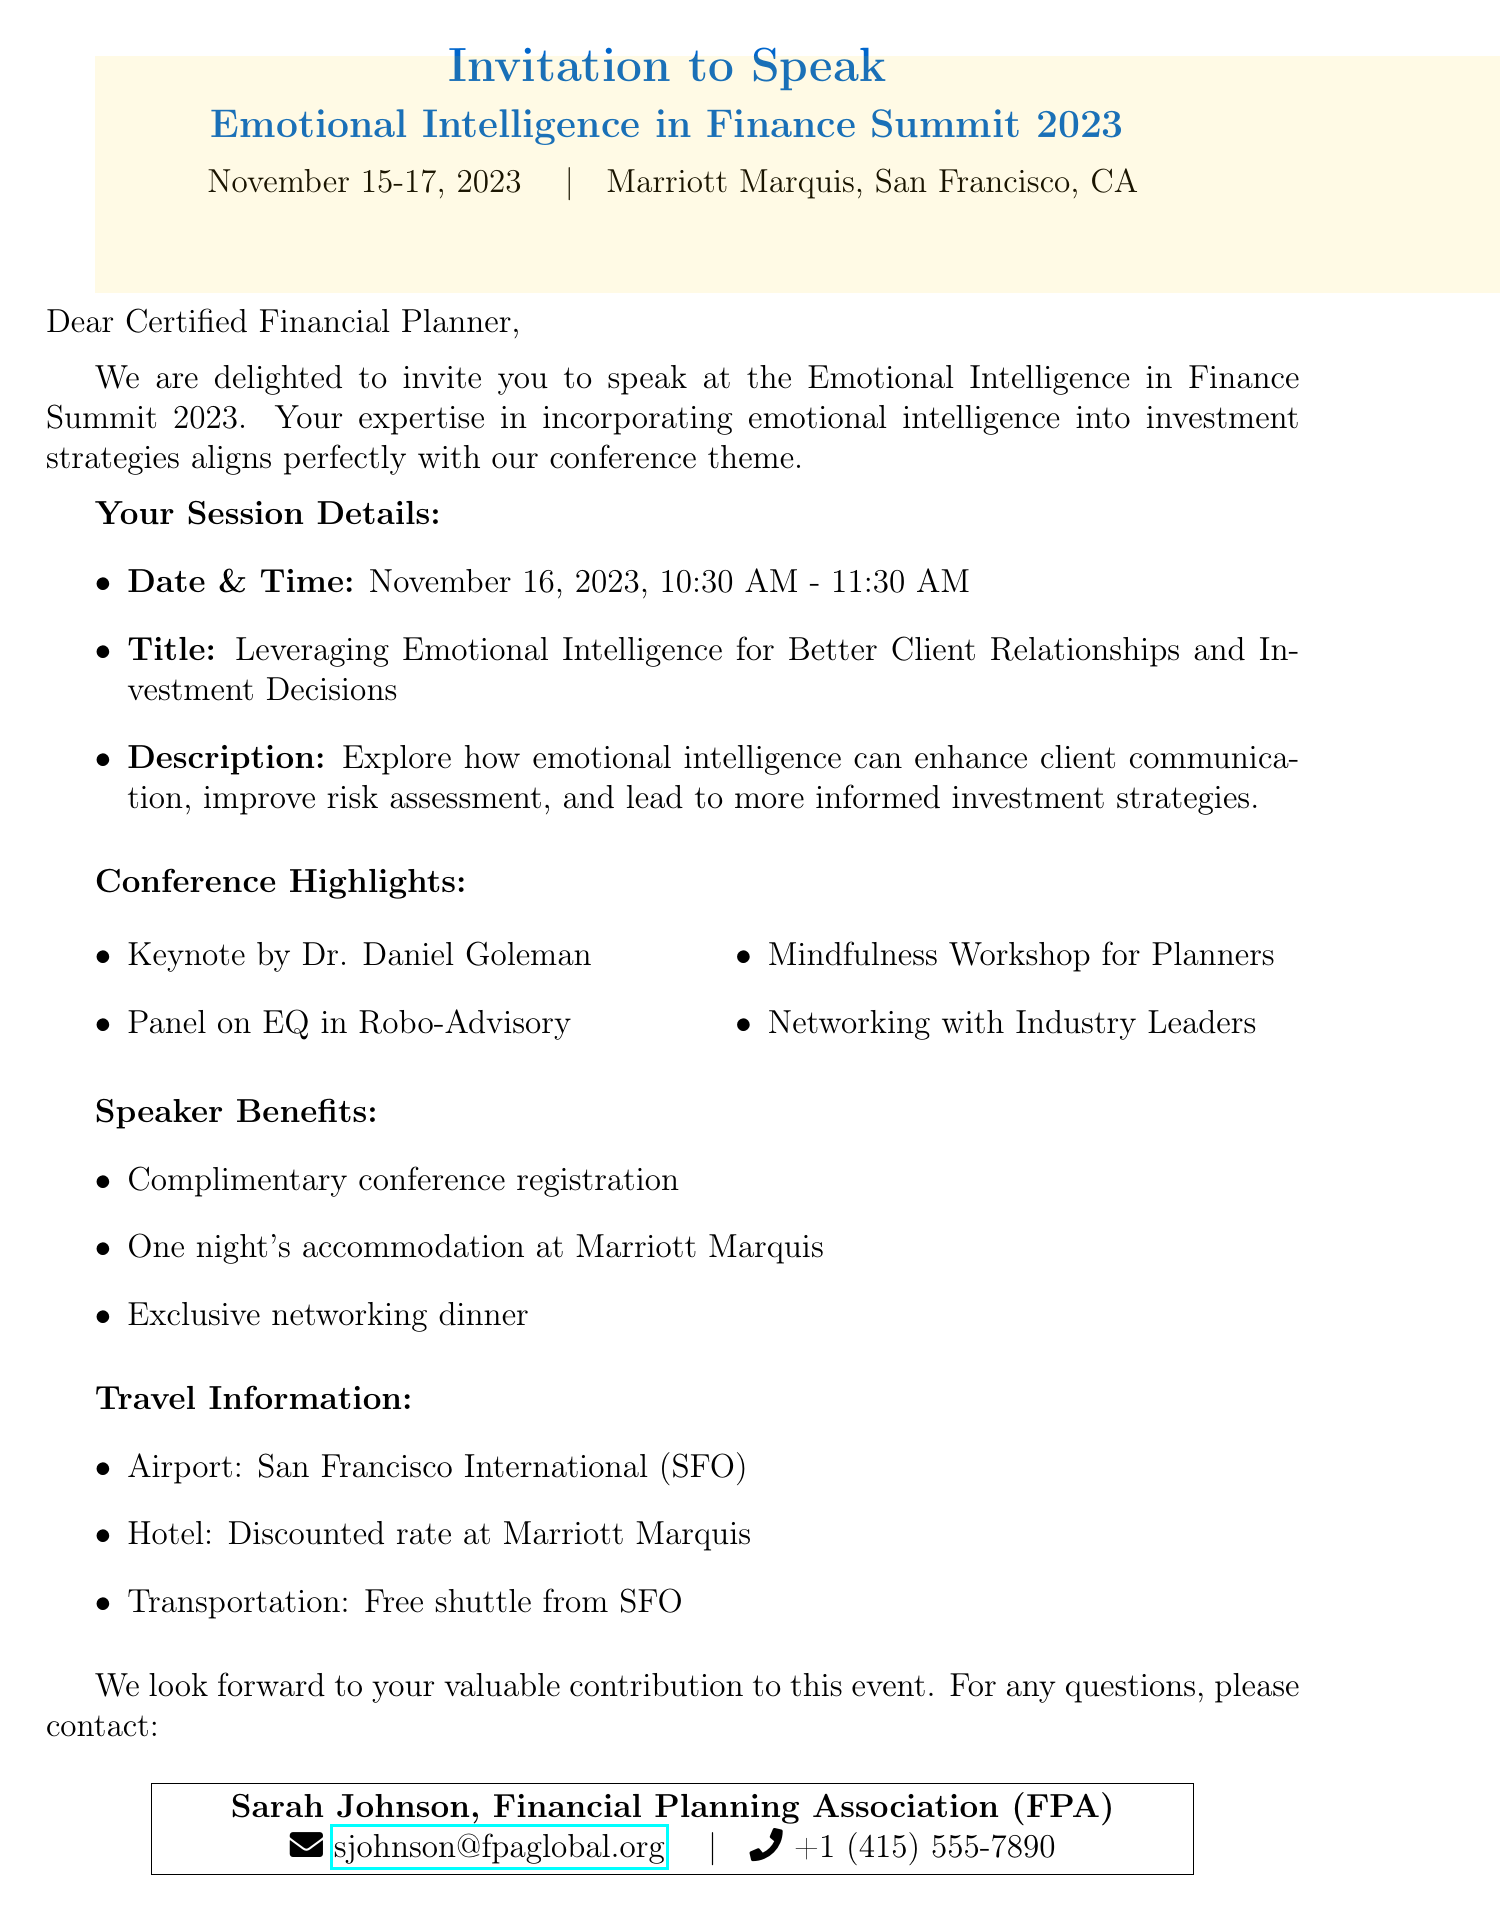What is the name of the conference? The conference is titled "Emotional Intelligence in Finance Summit 2023."
Answer: Emotional Intelligence in Finance Summit 2023 What are the speaking date and time? The speaking date and time indicated in the invitation are November 16, 2023, from 10:30 AM to 11:30 AM.
Answer: November 16, 2023, 10:30 AM - 11:30 AM Who is the keynote speaker? The keynote speaker mentioned in the agenda is Dr. Daniel Goleman.
Answer: Dr. Daniel Goleman What is included in the speaker benefits? The speaker benefits list includes complimentary conference registration, one night's accommodation, and a networking dinner.
Answer: Complimentary conference registration, one night's accommodation at Marriott Marquis, networking dinner with industry leaders What airport is recommended for travel? The document specifies that San Francisco International Airport (SFO) is the recommended airport for travel.
Answer: San Francisco International Airport (SFO) What is the session title? The title of the session that the speaker is invited to present is "Leveraging Emotional Intelligence for Better Client Relationships and Investment Decisions."
Answer: Leveraging Emotional Intelligence for Better Client Relationships and Investment Decisions What organization is hosting the conference? The organization responsible for hosting the event is the Financial Planning Association (FPA).
Answer: Financial Planning Association (FPA) What kind of workshop is included in the agenda? One of the highlights mentioned in the agenda is a mindfulness workshop for financial planners.
Answer: Mindfulness Workshop for Planners What is the venue for the conference? The venue specified for the conference is Marriott Marquis in San Francisco, CA.
Answer: Marriott Marquis, San Francisco, CA 